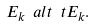<formula> <loc_0><loc_0><loc_500><loc_500>E _ { k } \ a l t \ t E _ { k } .</formula> 